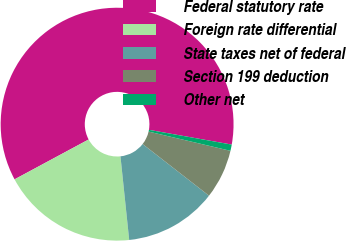Convert chart to OTSL. <chart><loc_0><loc_0><loc_500><loc_500><pie_chart><fcel>Federal statutory rate<fcel>Foreign rate differential<fcel>State taxes net of federal<fcel>Section 199 deduction<fcel>Other net<nl><fcel>60.66%<fcel>18.8%<fcel>12.82%<fcel>6.85%<fcel>0.87%<nl></chart> 